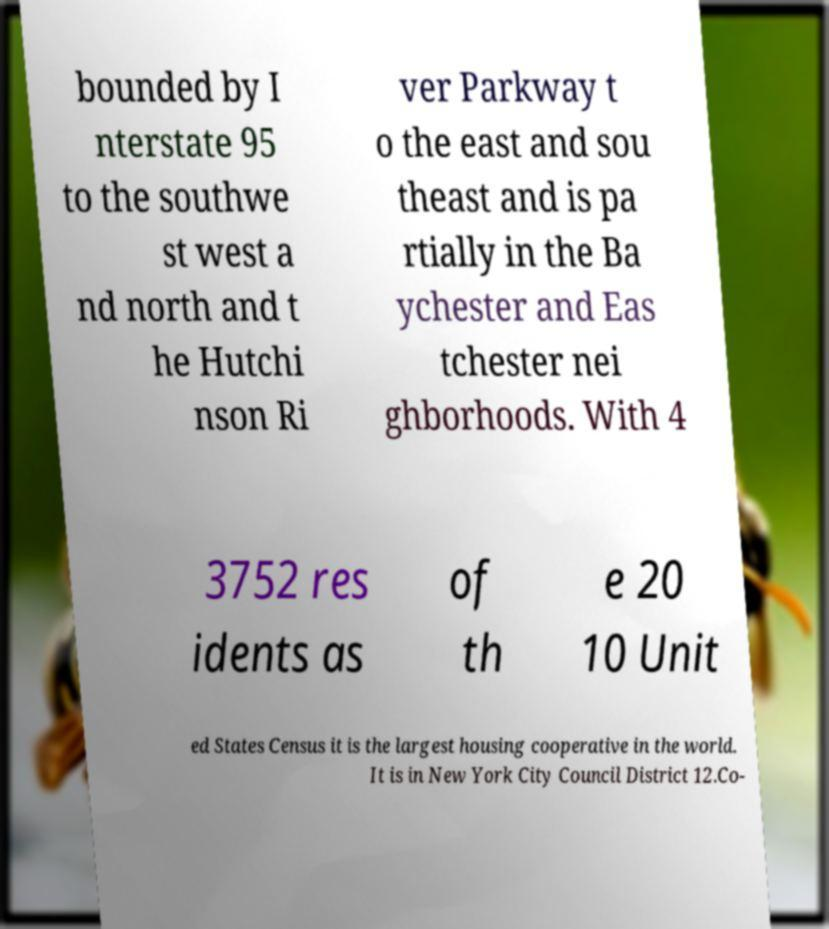Could you assist in decoding the text presented in this image and type it out clearly? bounded by I nterstate 95 to the southwe st west a nd north and t he Hutchi nson Ri ver Parkway t o the east and sou theast and is pa rtially in the Ba ychester and Eas tchester nei ghborhoods. With 4 3752 res idents as of th e 20 10 Unit ed States Census it is the largest housing cooperative in the world. It is in New York City Council District 12.Co- 